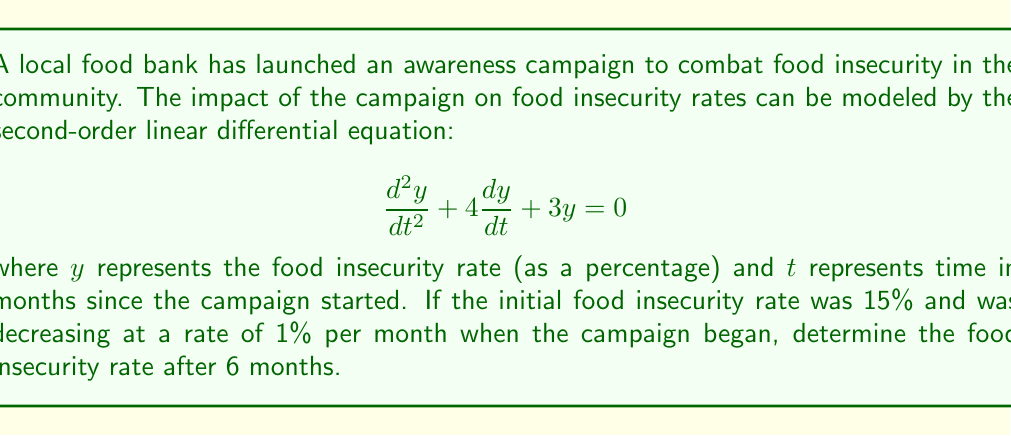Show me your answer to this math problem. To solve this problem, we need to follow these steps:

1) First, we need to find the general solution to the differential equation. The characteristic equation is:

   $$r^2 + 4r + 3 = 0$$

2) Solving this equation:
   $$(r + 1)(r + 3) = 0$$
   $$r = -1 \text{ or } r = -3$$

3) Therefore, the general solution is:

   $$y = C_1e^{-t} + C_2e^{-3t}$$

4) Now we need to use the initial conditions to find $C_1$ and $C_2$. We know that:

   At $t = 0$, $y = 15$ (initial rate)
   At $t = 0$, $\frac{dy}{dt} = -1$ (initial rate of change)

5) Using the first condition:

   $$15 = C_1 + C_2$$

6) For the second condition, we differentiate $y$:

   $$\frac{dy}{dt} = -C_1e^{-t} - 3C_2e^{-3t}$$

   At $t = 0$:

   $$-1 = -C_1 - 3C_2$$

7) Now we have a system of equations:

   $$C_1 + C_2 = 15$$
   $$C_1 + 3C_2 = 1$$

8) Solving this system:

   $$C_1 = 22, C_2 = -7$$

9) Therefore, the particular solution is:

   $$y = 22e^{-t} - 7e^{-3t}$$

10) To find the food insecurity rate after 6 months, we substitute $t = 6$:

    $$y = 22e^{-6} - 7e^{-18}$$
Answer: The food insecurity rate after 6 months is approximately 0.62%. 